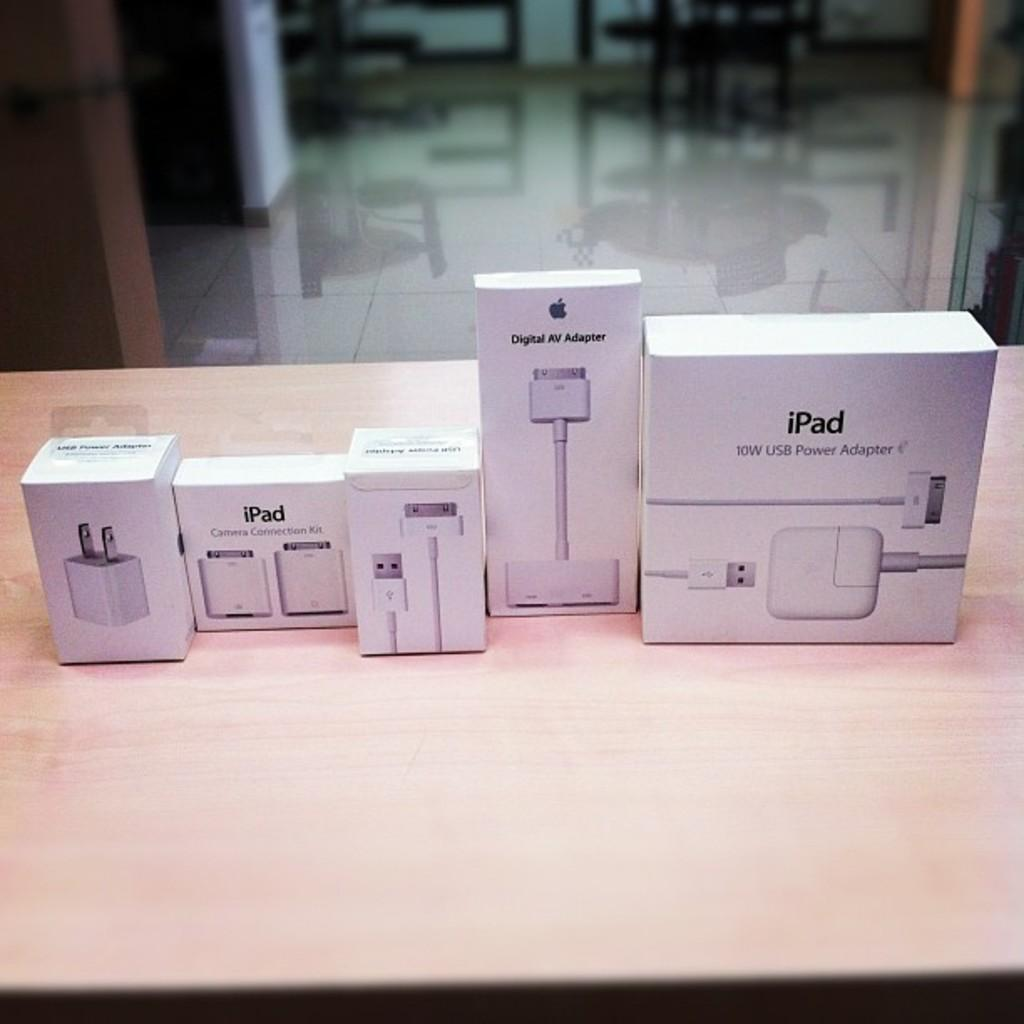<image>
Give a short and clear explanation of the subsequent image. Several iPad products are lined up on a display table. 